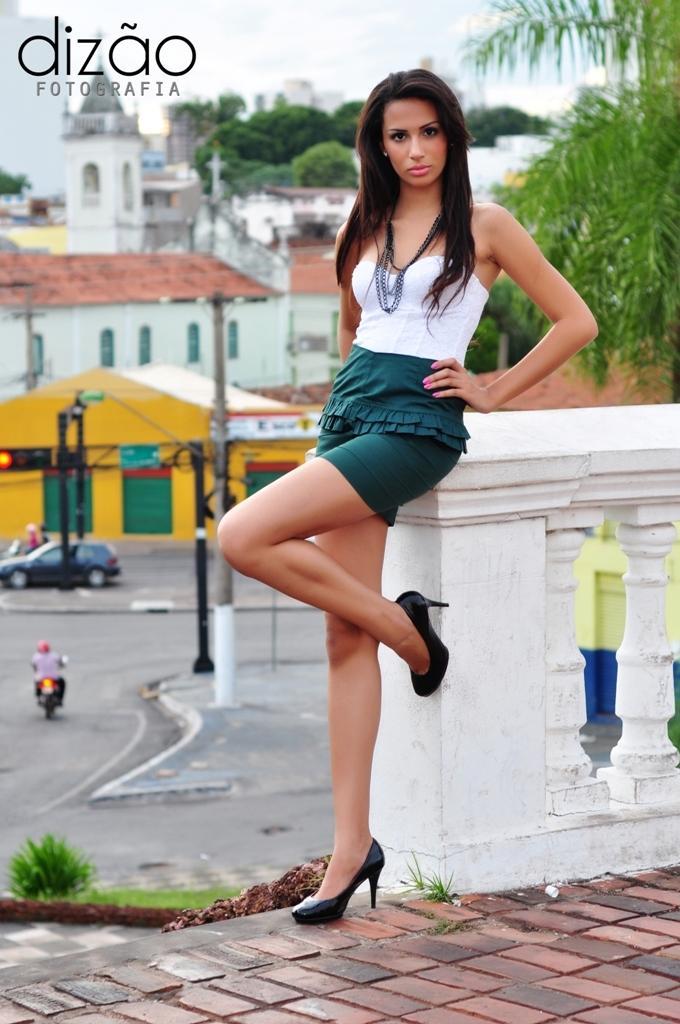Can you describe this image briefly? In this image there is a lady leaning to a railing, in the background there is a road, on that road there are cars and bikes and there are houses, trees, in the top left there is text. 